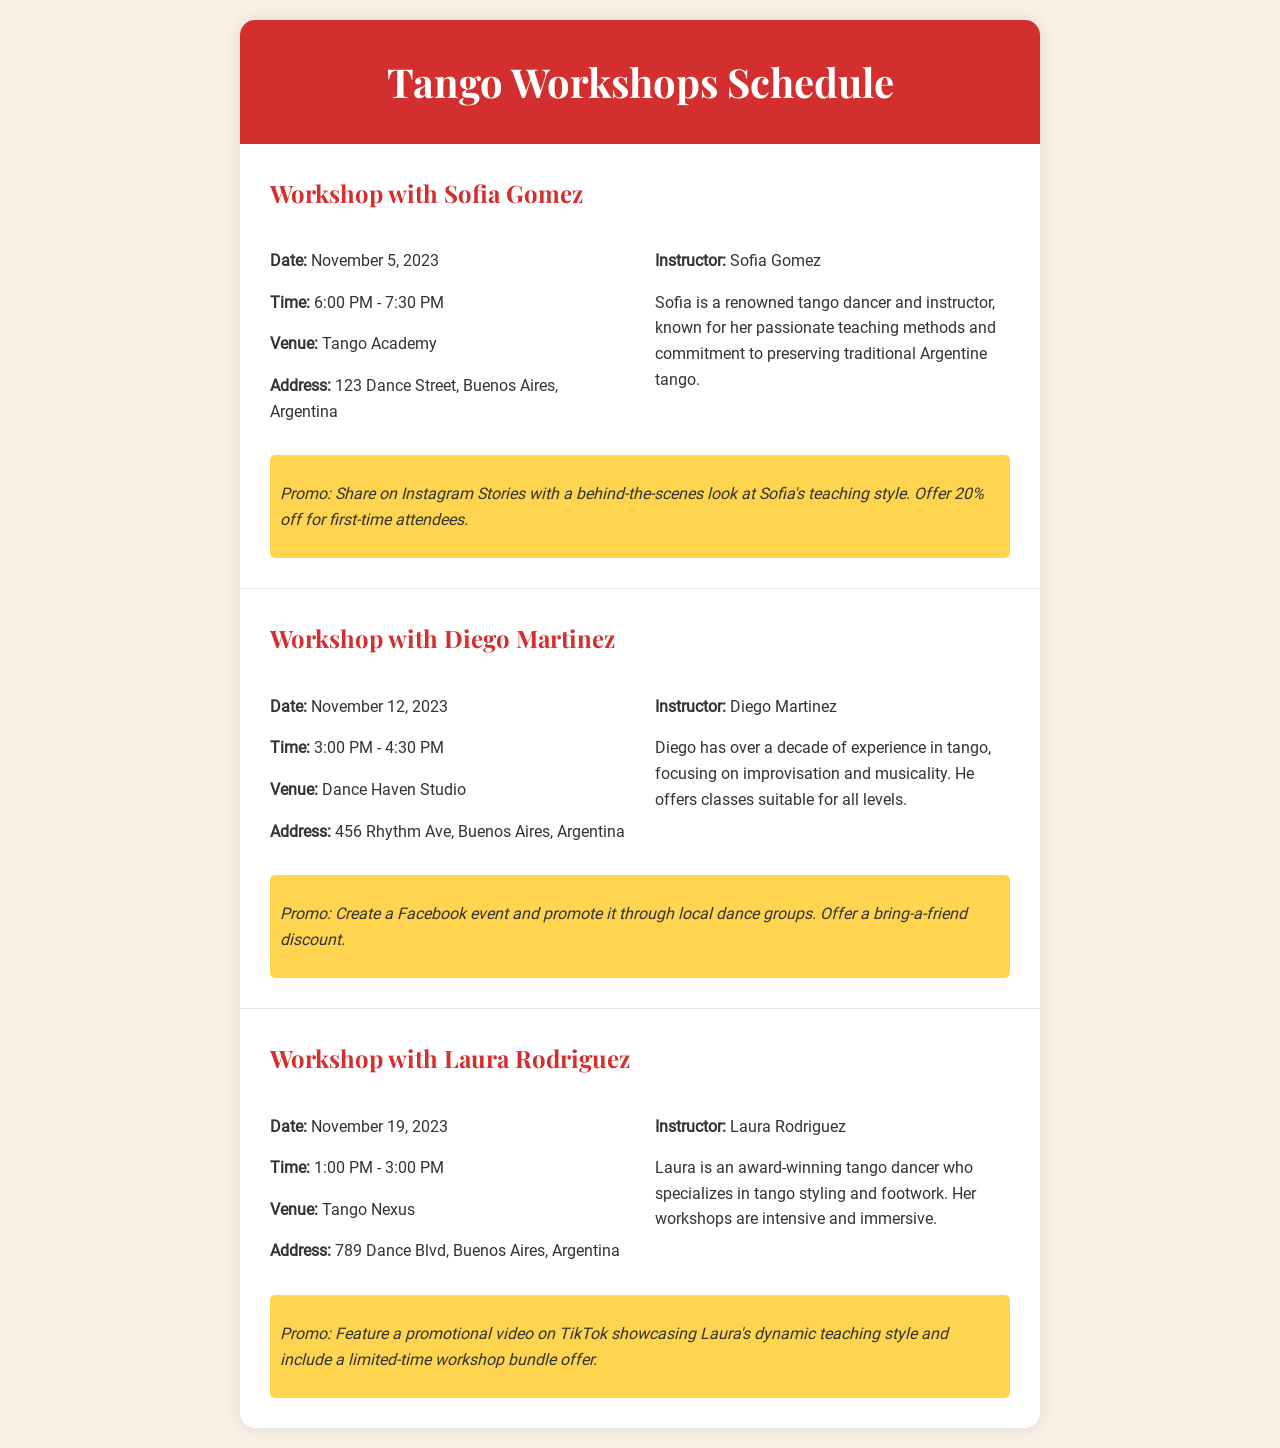What is the date of the workshop with Sofia Gomez? The date of the workshop with Sofia Gomez is mentioned in the document as November 5, 2023.
Answer: November 5, 2023 What time does the workshop with Diego Martinez start? The starting time of the workshop with Diego Martinez is specified as 3:00 PM.
Answer: 3:00 PM Where is the venue for Laura Rodriguez's workshop? The venue for Laura Rodriguez's workshop is stated as Tango Nexus.
Answer: Tango Nexus Who is the instructor for the workshop on November 12, 2023? The instructor for the workshop on November 12, 2023 is identified in the document as Diego Martinez.
Answer: Diego Martinez What type of discount is offered for first-time attendees in Sofia's workshop? The document states a 20% off discount for first-time attendees for Sofia's workshop.
Answer: 20% off How long is the workshop with Laura Rodriguez? The duration of Laura Rodriguez's workshop is given as 2 hours, from 1:00 PM to 3:00 PM.
Answer: 2 hours What is the promotional plan for Diego's workshop? The promotional plan for Diego's workshop involves creating a Facebook event and promoting through local dance groups.
Answer: Create a Facebook event Which instructor specializes in tango styling and footwork? The document indicates that Laura Rodriguez specializes in tango styling and footwork.
Answer: Laura Rodriguez What is the address of the venue for Diego's workshop? The address for the venue of Diego's workshop is mentioned as 456 Rhythm Ave, Buenos Aires, Argentina.
Answer: 456 Rhythm Ave, Buenos Aires, Argentina 